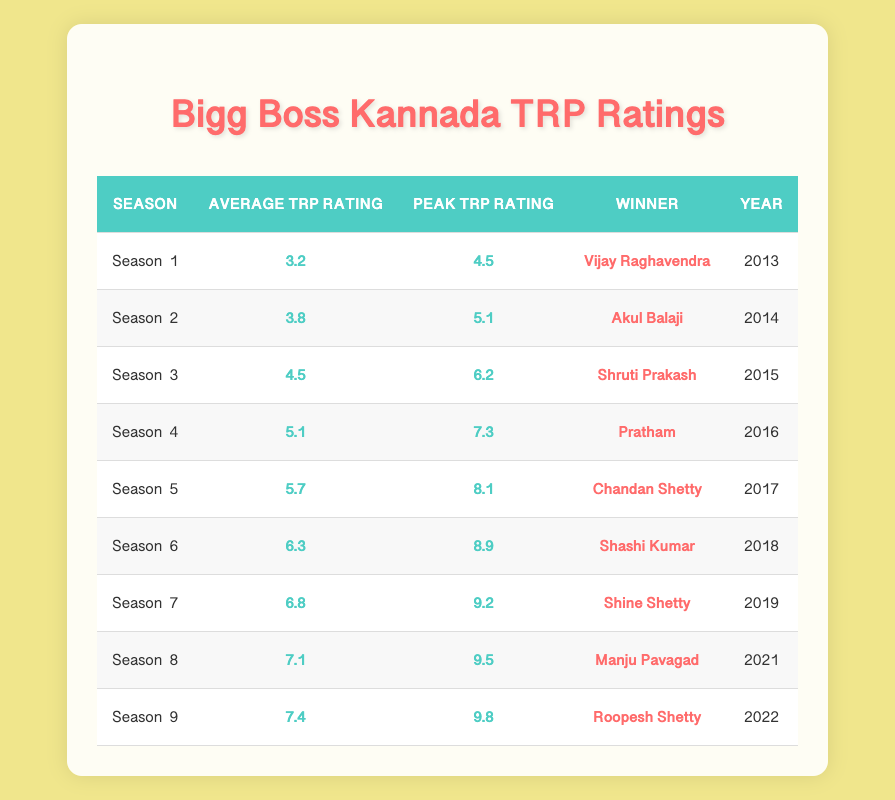What was the average TRP rating for Season 4? The table shows that Season 4 has an average TRP rating of 5.1, as listed in the "Average TRP Rating" column for that specific season.
Answer: 5.1 Which season had the highest peak TRP rating? By comparing the "Peak TRP Rating" values for all seasons, Season 9 has the highest peak TRP rating of 9.8.
Answer: Season 9 Is the winner of Season 6 Shashi Kumar? Looking at the "Winner" column for Season 6, it is stated that Shashi Kumar is indeed the winner.
Answer: Yes How much did the average TRP rating increase from Season 5 to Season 8? The average TRP rating for Season 5 is 5.7 and for Season 8 is 7.1. The increase is calculated as 7.1 - 5.7 = 1.4.
Answer: 1.4 In which year did Season 3 take place? The table lists the year associated with Season 3 in the "Year" column, which is 2015.
Answer: 2015 What is the difference between the peak TRP rating of Season 7 and Season 9? Season 7 has a peak TRP rating of 9.2, while Season 9 has 9.8. The difference is calculated as 9.8 - 9.2 = 0.6.
Answer: 0.6 Which season had an average TRP rating lower than 6? Reviewing the "Average TRP Rating" column, Seasons 1 (3.2), 2 (3.8), and 3 (4.5) all have ratings lower than 6.
Answer: Seasons 1, 2, 3 Did any season have an average TRP rating of 6.0? Checking the "Average TRP Rating" column, there is no season with an exact average TRP rating of 6.0; the closest are 5.7 and 6.3.
Answer: No Which winner had the highest peak TRP rating in their season? Season 9 had the highest peak TRP rating of 9.8 and its winner is Roopesh Shetty, making him the winner with the highest peak TRP.
Answer: Roopesh Shetty 